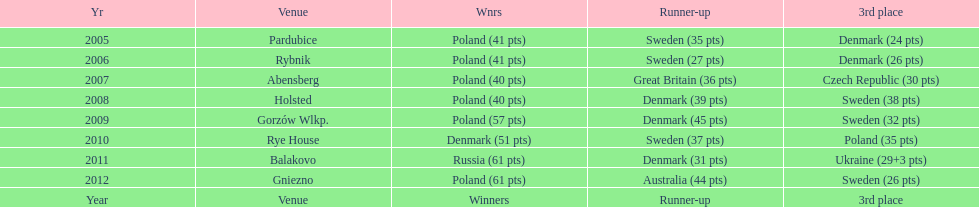After their first place win in 2009, how did poland place the next year at the speedway junior world championship? 3rd place. 